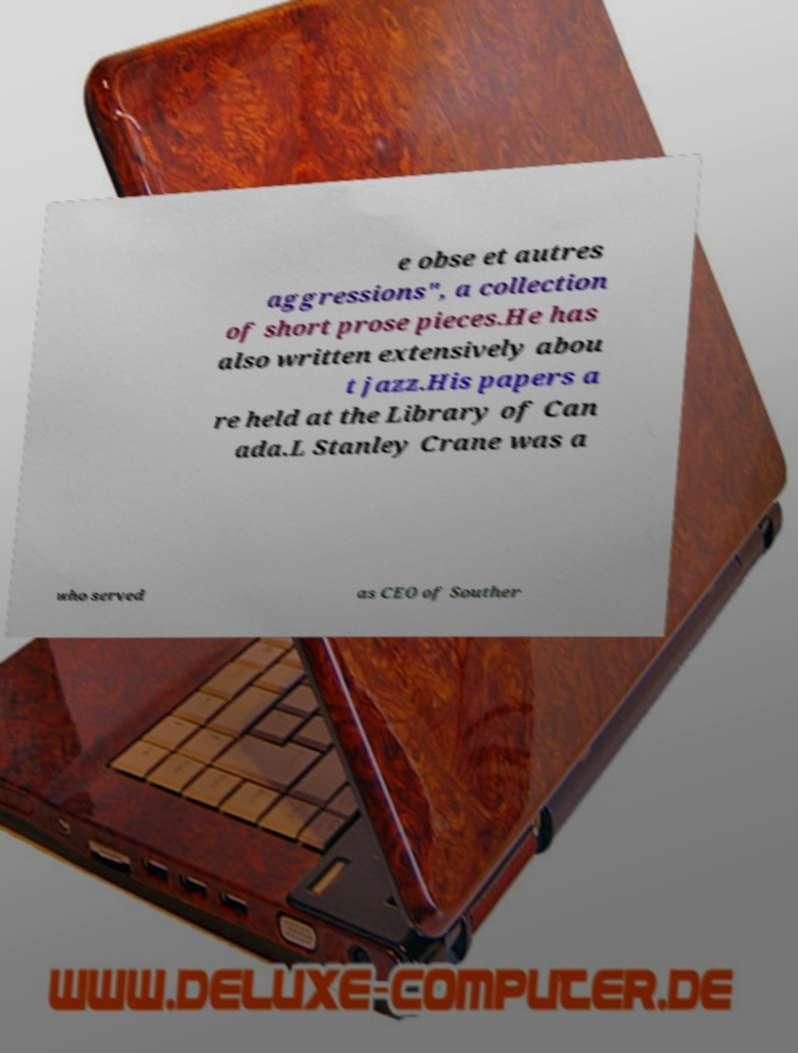I need the written content from this picture converted into text. Can you do that? e obse et autres aggressions", a collection of short prose pieces.He has also written extensively abou t jazz.His papers a re held at the Library of Can ada.L Stanley Crane was a who served as CEO of Souther 